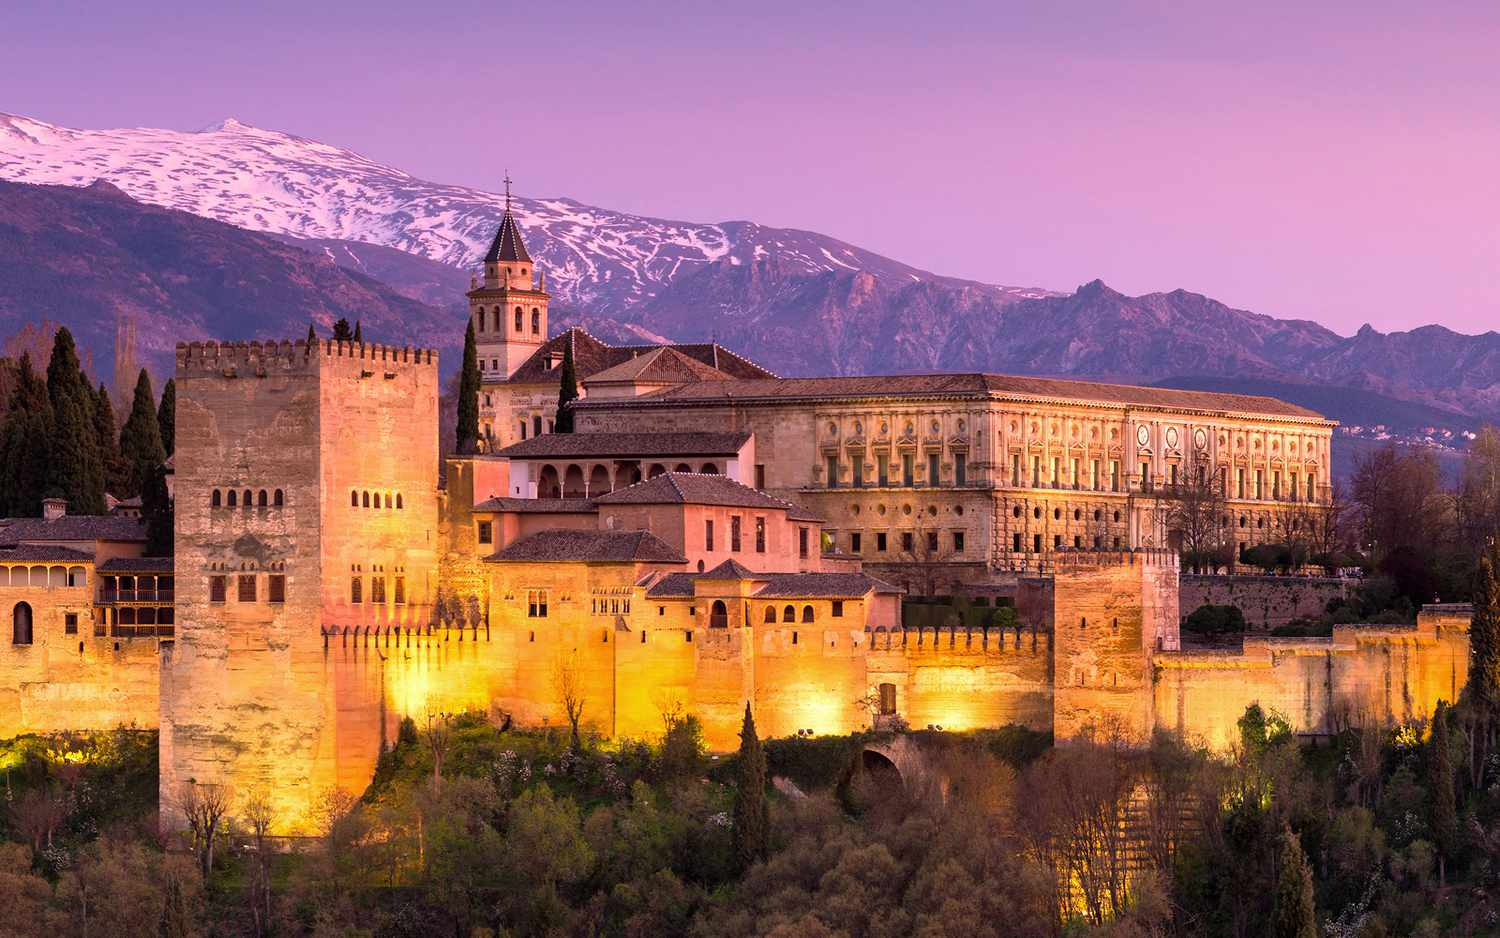How does the Alhambra interact with its natural surroundings? The Alhambra's design shows a profound respect and deliberate integration with its natural surroundings. Like a crown atop the Sabika hill, it overlooks the city while offering panoramic views of the Sierra Nevada mountain range. Its numerous windows and balconies were strategically placed to frame the picturesque landscape, while gardens like the Generalife contain an array of plants that reflect the local flora. The architects utilized the flow of natural water from the mountains for the complex's decorative fountains and irrigation, creating a verdant oasis within its walls. This thoughtful positioning and use of the environment convey a seamless blend between human artistry and the natural world. 